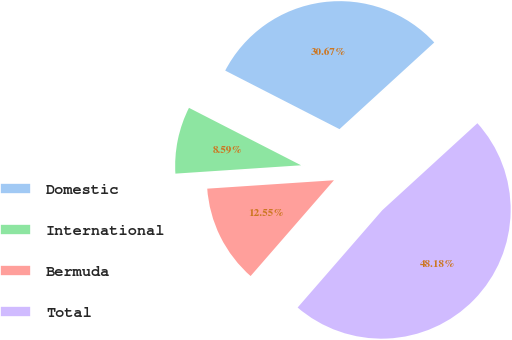Convert chart. <chart><loc_0><loc_0><loc_500><loc_500><pie_chart><fcel>Domestic<fcel>International<fcel>Bermuda<fcel>Total<nl><fcel>30.67%<fcel>8.59%<fcel>12.55%<fcel>48.18%<nl></chart> 